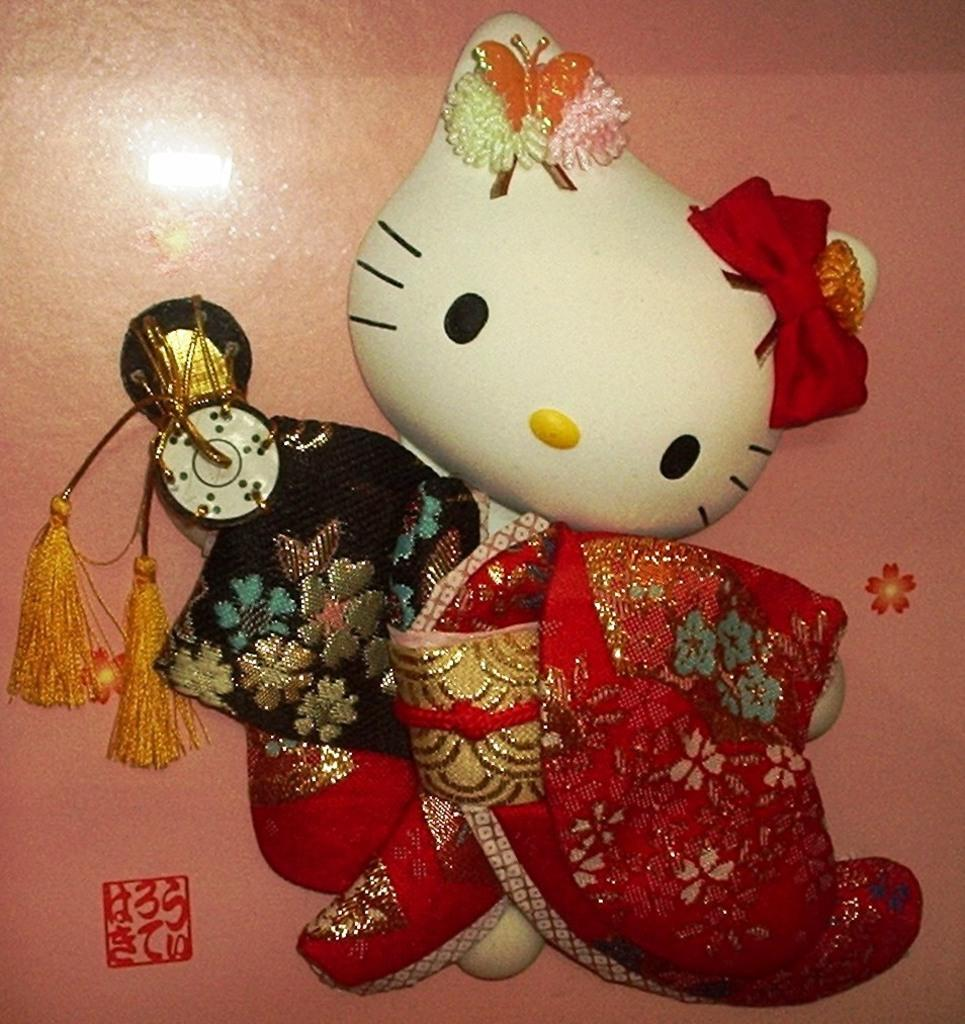What type of toy is in the image? There is a toy cat in the image. How is the toy cat covered? The toy cat is covered in red cloth. What can be said about the wall in the image? The wall in the image is painted. Can you tell me how many snakes are slithering on the painted wall in the image? There are no snakes present in the image; the wall is painted, but no snakes are visible. 